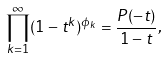<formula> <loc_0><loc_0><loc_500><loc_500>\prod _ { k = 1 } ^ { \infty } ( 1 - t ^ { k } ) ^ { \phi _ { k } } = \frac { P ( - t ) } { 1 - t } ,</formula> 